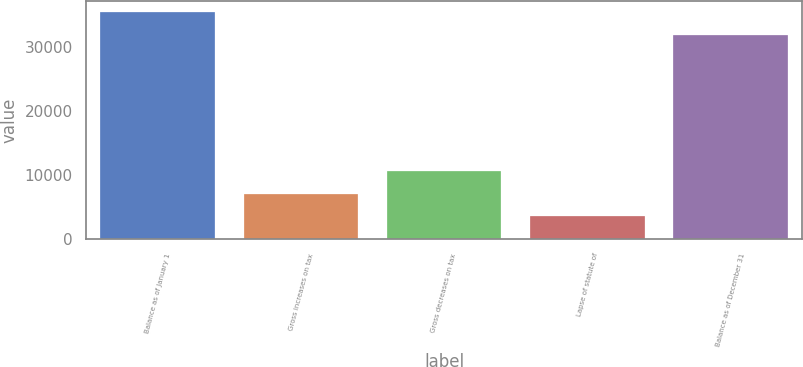Convert chart. <chart><loc_0><loc_0><loc_500><loc_500><bar_chart><fcel>Balance as of January 1<fcel>Gross increases on tax<fcel>Gross decreases on tax<fcel>Lapse of statute of<fcel>Balance as of December 31<nl><fcel>35438.9<fcel>7141.8<fcel>10677.7<fcel>3605.9<fcel>31903<nl></chart> 